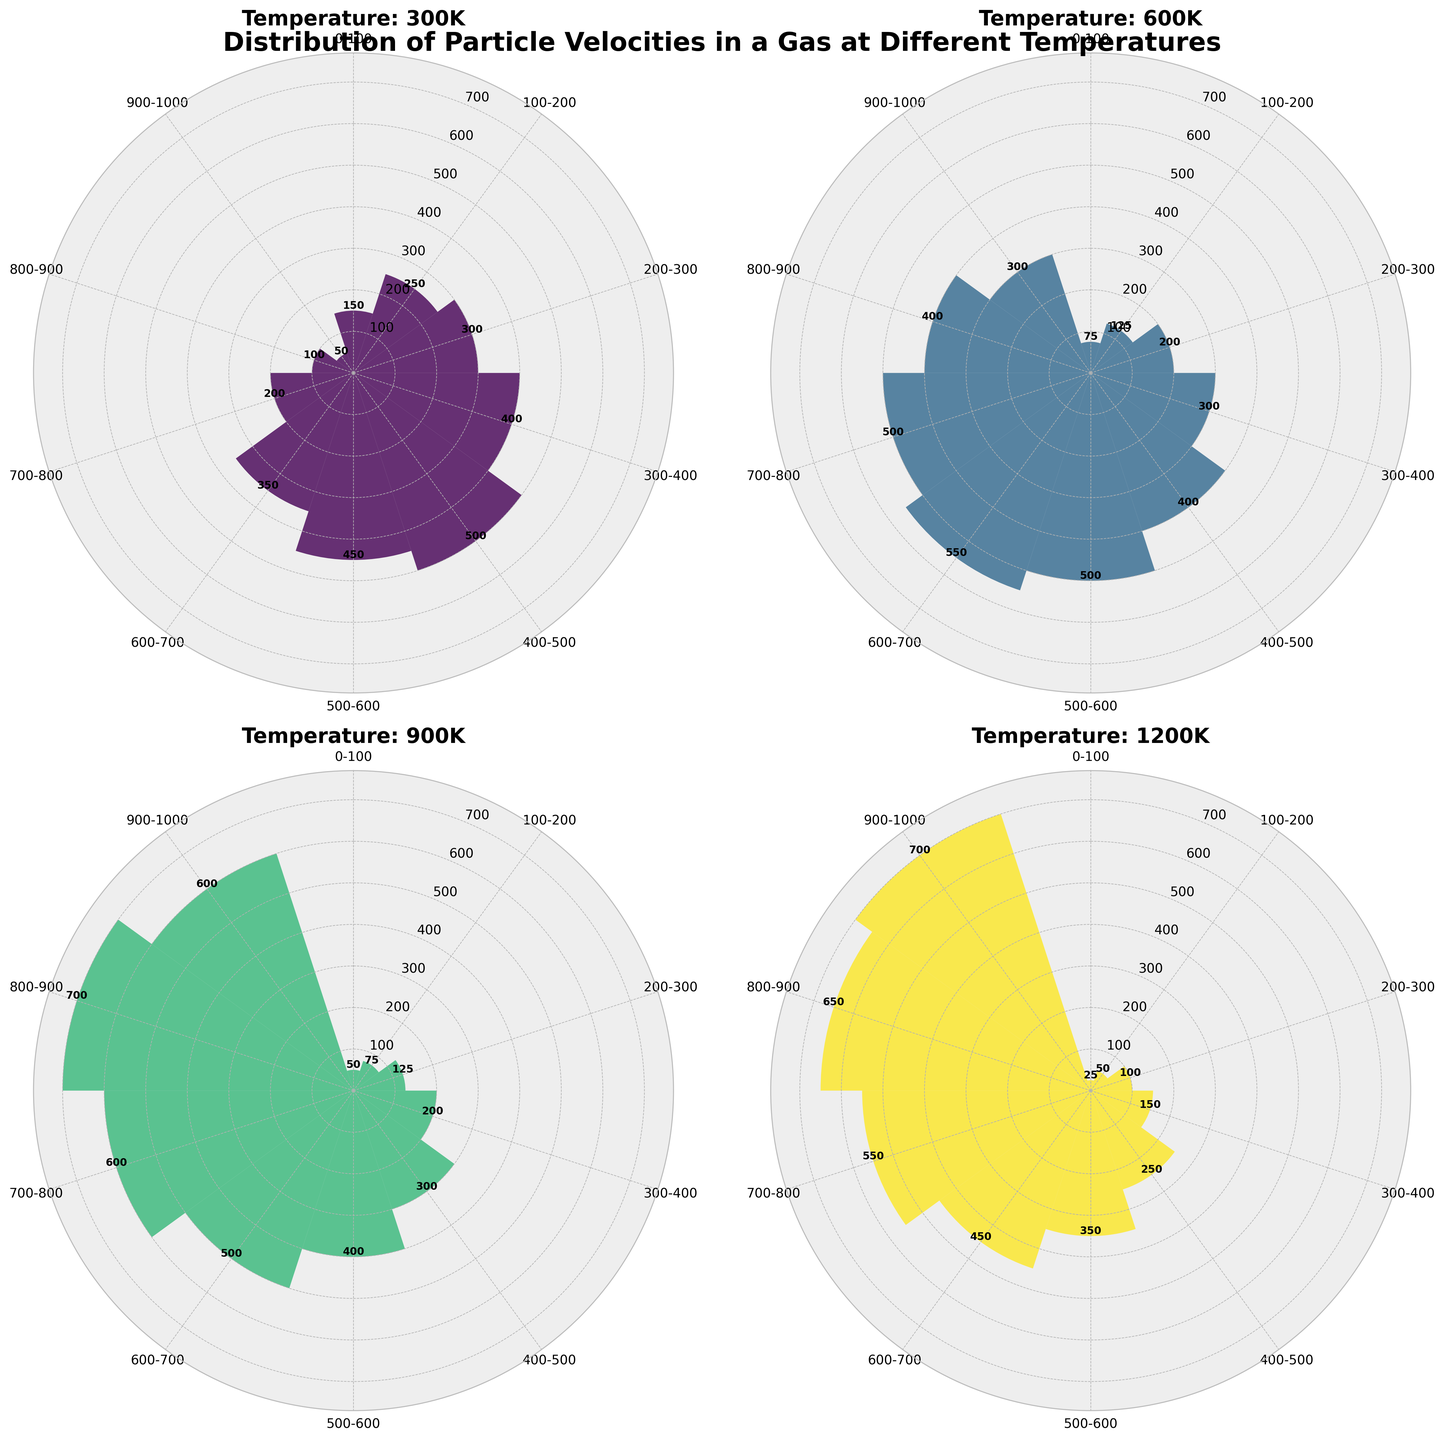What is the title of the figure? The title of the figure is typically placed at the top of the chart or plot. In this case, it is "Distribution of Particle Velocities in a Gas at Different Temperatures", which summarises the content and focus of the rose charts.
Answer: Distribution of Particle Velocities in a Gas at Different Temperatures What is the maximum particle count at 600K? By examining the radial extent of the bars in the rose chart for 600K, one can identify the longest bar. The label at the top of the bar should indicate the maximum particle count.
Answer: 550 Which temperature has the widest range of velocity bins with at least 400 particles? By observing the charts, one should count the velocity bins with at least 400 particles for each temperature and determine which has the most.  For 300K, it’s two bins (400-500, 500-600). For 600K, it’s three bins (500-600, 600-700, and 700-800). For 900K, it's five bins (500-600, 600-700, 700-800, 800-900, and 900-1000). For 1200K, it’s four bins (700-800, 800-900, and 900-1000). Thus, 900K has the widest range.
Answer: 900K How does the particle count at the bin 800-900 compare between 300K and 1200K? Locate the 800-900 bin in both the 300K and 1200K rose charts. For 300K, the particle count is 100. At 1200K, the particle count is 650, making it significantly higher at 1200K compared to 300K.
Answer: 1200K has 650, 300K has 100 Which two temperature charts have the least and greatest maximum particle counts, respectively? The maximum particle count is identified by the longest radial bar in each chart. For each temperature, determine the highest count. 300K has a maximum of 500. 600K has a maximum of 550. 900K has a maximum of 700. 1200K also has a maximum of 700. Thus, 300K has the least maximum particle count, and both 900K and 1200K have the greatest.
Answer: Least: 300K, Greatest: 900K and 1200K At what temperature does the bin 200-300 have the lowest particle count and what is that count? Comparing the 200-300 bin across all temperatures: 300K is 300, 600K is 200, 900K is 125, 1200K is 100. Hence, 1200K has the lowest count in that bin with 100 particles.
Answer: Temperature is 1200K, count is 100 How does the distribution of particles shift as the temperature increases from 600K to 900K? Observing the charts for 600K and 900K, at 600K most of the particles are concentrated in the middle bins (400-800). At 900K, the distribution shifts towards higher velocity bins with counts increasing in higher ranges (500-1000). This shows particles are more spread out toward higher velocities as the temperature increases.
Answer: Shift towards higher velocity bins What is the combined particle count in the first three velocity bins at 300K? Summing the particle counts of the first three bins (0-100, 100-200, 200-300) at 300K: 150 (0-100) + 250 (100-200) + 300 (200-300) = 700.
Answer: 700 